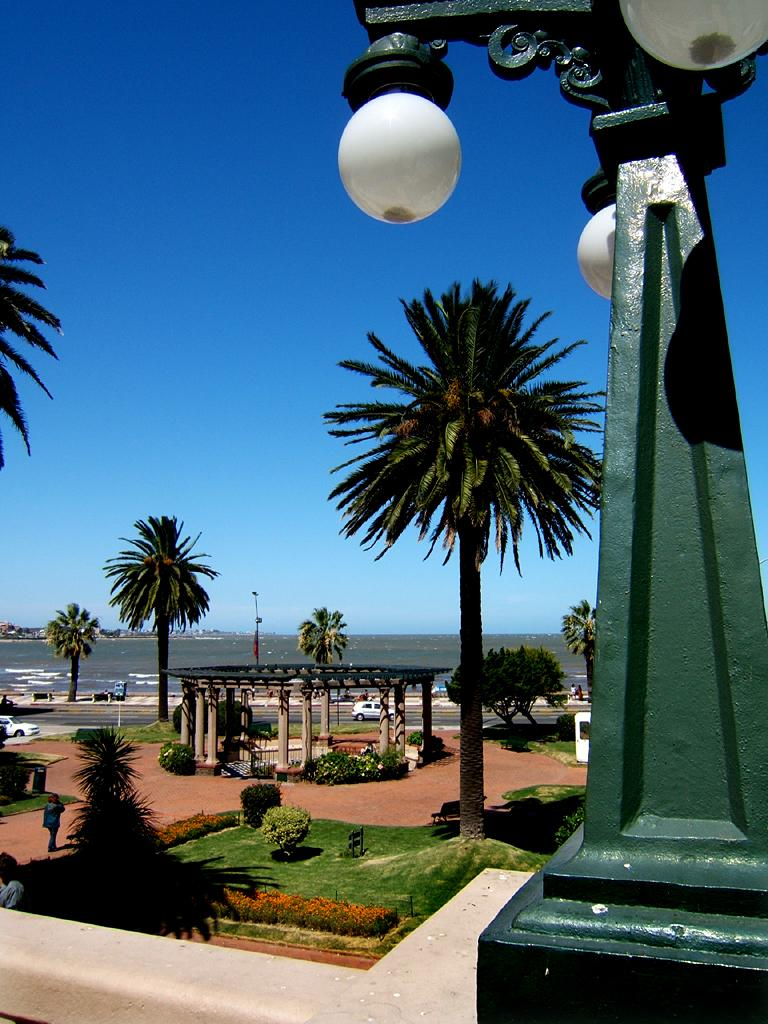What type of vegetation is present on the land in the image? There are trees on the land in the image. What can be seen on the right side of the image? There is a green color pillar on the right side of the image. What is attached to the pillar? Lamps are fixed to the pillar. What is visible in the background of the image? There is a sky visible in the background of the image. What type of tree is growing on the back of the pillar in the image? There is no tree growing on the back of the pillar in the image; the pillar is green in color and has lamps attached to it. How many dimes can be seen on the ground in the image? There are no dimes present in the image. 